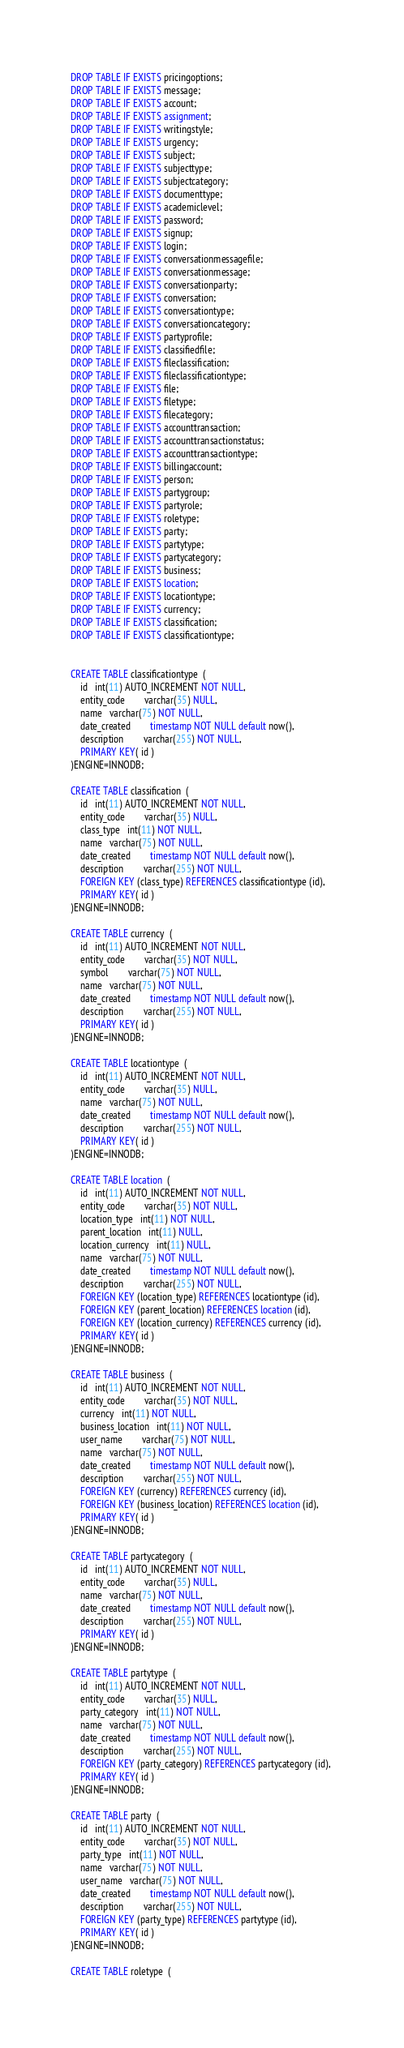Convert code to text. <code><loc_0><loc_0><loc_500><loc_500><_SQL_>DROP TABLE IF EXISTS pricingoptions;
DROP TABLE IF EXISTS message;
DROP TABLE IF EXISTS account;
DROP TABLE IF EXISTS assignment;
DROP TABLE IF EXISTS writingstyle;
DROP TABLE IF EXISTS urgency;
DROP TABLE IF EXISTS subject;
DROP TABLE IF EXISTS subjecttype;
DROP TABLE IF EXISTS subjectcategory;
DROP TABLE IF EXISTS documenttype;
DROP TABLE IF EXISTS academiclevel;
DROP TABLE IF EXISTS password;
DROP TABLE IF EXISTS signup;
DROP TABLE IF EXISTS login;
DROP TABLE IF EXISTS conversationmessagefile;
DROP TABLE IF EXISTS conversationmessage;
DROP TABLE IF EXISTS conversationparty;
DROP TABLE IF EXISTS conversation;
DROP TABLE IF EXISTS conversationtype;
DROP TABLE IF EXISTS conversationcategory;
DROP TABLE IF EXISTS partyprofile;
DROP TABLE IF EXISTS classifiedfile;
DROP TABLE IF EXISTS fileclassification;
DROP TABLE IF EXISTS fileclassificationtype;
DROP TABLE IF EXISTS file;
DROP TABLE IF EXISTS filetype;
DROP TABLE IF EXISTS filecategory;
DROP TABLE IF EXISTS accounttransaction;
DROP TABLE IF EXISTS accounttransactionstatus;
DROP TABLE IF EXISTS accounttransactiontype;
DROP TABLE IF EXISTS billingaccount;
DROP TABLE IF EXISTS person;
DROP TABLE IF EXISTS partygroup;
DROP TABLE IF EXISTS partyrole;
DROP TABLE IF EXISTS roletype;
DROP TABLE IF EXISTS party;
DROP TABLE IF EXISTS partytype;
DROP TABLE IF EXISTS partycategory;
DROP TABLE IF EXISTS business;
DROP TABLE IF EXISTS location;
DROP TABLE IF EXISTS locationtype;
DROP TABLE IF EXISTS currency;
DROP TABLE IF EXISTS classification;
DROP TABLE IF EXISTS classificationtype;


CREATE TABLE classificationtype  ( 
	id   int(11) AUTO_INCREMENT NOT NULL,
	entity_code   		varchar(35) NULL,
	name   varchar(75) NOT NULL,
	date_created   		timestamp NOT NULL default now(),
	description   		varchar(255) NOT NULL,
	PRIMARY KEY( id )
)ENGINE=INNODB;

CREATE TABLE classification  ( 
	id   int(11) AUTO_INCREMENT NOT NULL,
	entity_code   		varchar(35) NULL,
   	class_type   int(11) NOT NULL,
	name   varchar(75) NOT NULL,
	date_created   		timestamp NOT NULL default now(),
	description   		varchar(255) NOT NULL,
 	FOREIGN KEY (class_type) REFERENCES classificationtype (id), 
	PRIMARY KEY( id )
)ENGINE=INNODB;

CREATE TABLE currency  ( 
	id   int(11) AUTO_INCREMENT NOT NULL,
	entity_code   		varchar(35) NOT NULL,
	symbol   		varchar(75) NOT NULL,
	name   varchar(75) NOT NULL,
	date_created   		timestamp NOT NULL default now(),
	description   		varchar(255) NOT NULL,
	PRIMARY KEY( id )
)ENGINE=INNODB;

CREATE TABLE locationtype  ( 
	id   int(11) AUTO_INCREMENT NOT NULL,
	entity_code   		varchar(35) NULL,
	name   varchar(75) NOT NULL,
	date_created   		timestamp NOT NULL default now(),
	description   		varchar(255) NOT NULL,
	PRIMARY KEY( id )
)ENGINE=INNODB;

CREATE TABLE location  ( 
	id   int(11) AUTO_INCREMENT NOT NULL,
	entity_code   		varchar(35) NOT NULL,
   	location_type   int(11) NOT NULL,
   	parent_location   int(11) NULL,
   	location_currency   int(11) NULL,
	name   varchar(75) NOT NULL,
	date_created   		timestamp NOT NULL default now(),
	description   		varchar(255) NOT NULL,
 	FOREIGN KEY (location_type) REFERENCES locationtype (id), 
 	FOREIGN KEY (parent_location) REFERENCES location (id), 
 	FOREIGN KEY (location_currency) REFERENCES currency (id), 
	PRIMARY KEY( id )
)ENGINE=INNODB;

CREATE TABLE business  ( 
	id   int(11) AUTO_INCREMENT NOT NULL,
	entity_code   		varchar(35) NOT NULL,
   	currency   int(11) NOT NULL,
   	business_location   int(11) NOT NULL,
	user_name   		varchar(75) NOT NULL,
	name   varchar(75) NOT NULL,
	date_created   		timestamp NOT NULL default now(),
	description   		varchar(255) NOT NULL,
 	FOREIGN KEY (currency) REFERENCES currency (id), 
 	FOREIGN KEY (business_location) REFERENCES location (id), 
	PRIMARY KEY( id )
)ENGINE=INNODB;

CREATE TABLE partycategory  ( 
	id   int(11) AUTO_INCREMENT NOT NULL,
	entity_code   		varchar(35) NULL,
	name   varchar(75) NOT NULL,
	date_created   		timestamp NOT NULL default now(),
	description   		varchar(255) NOT NULL,
	PRIMARY KEY( id )
)ENGINE=INNODB;

CREATE TABLE partytype  ( 
	id   int(11) AUTO_INCREMENT NOT NULL,
	entity_code   		varchar(35) NULL,
   	party_category   int(11) NOT NULL,
	name   varchar(75) NOT NULL,
	date_created   		timestamp NOT NULL default now(),
	description   		varchar(255) NOT NULL,
 	FOREIGN KEY (party_category) REFERENCES partycategory (id), 
	PRIMARY KEY( id )
)ENGINE=INNODB;

CREATE TABLE party  ( 
	id   int(11) AUTO_INCREMENT NOT NULL,
	entity_code   		varchar(35) NOT NULL,
   	party_type   int(11) NOT NULL,
	name   varchar(75) NOT NULL,
	user_name   varchar(75) NOT NULL,
	date_created   		timestamp NOT NULL default now(),
	description   		varchar(255) NOT NULL,
 	FOREIGN KEY (party_type) REFERENCES partytype (id), 
	PRIMARY KEY( id )
)ENGINE=INNODB;

CREATE TABLE roletype  ( </code> 